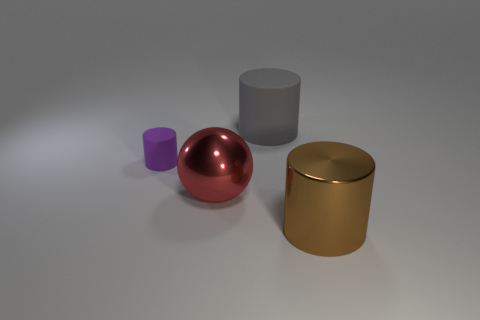Is there any other thing that is the same size as the purple thing?
Offer a very short reply. No. Is there a big brown cylinder made of the same material as the red sphere?
Provide a succinct answer. Yes. There is a gray object that is the same size as the red shiny thing; what is its material?
Keep it short and to the point. Rubber. What is the size of the purple cylinder behind the cylinder that is on the right side of the matte thing behind the small matte thing?
Provide a short and direct response. Small. There is a rubber thing that is behind the tiny cylinder; are there any matte cylinders that are on the left side of it?
Provide a short and direct response. Yes. Do the purple rubber object and the thing that is behind the small cylinder have the same shape?
Provide a short and direct response. Yes. There is a big cylinder that is on the left side of the big brown metallic cylinder; what is its color?
Your response must be concise. Gray. There is a purple thing that is behind the cylinder that is in front of the metal sphere; how big is it?
Your response must be concise. Small. There is a metal thing that is behind the large shiny cylinder; is its shape the same as the large brown metal object?
Provide a short and direct response. No. What is the material of the large gray thing that is the same shape as the purple thing?
Your answer should be very brief. Rubber. 